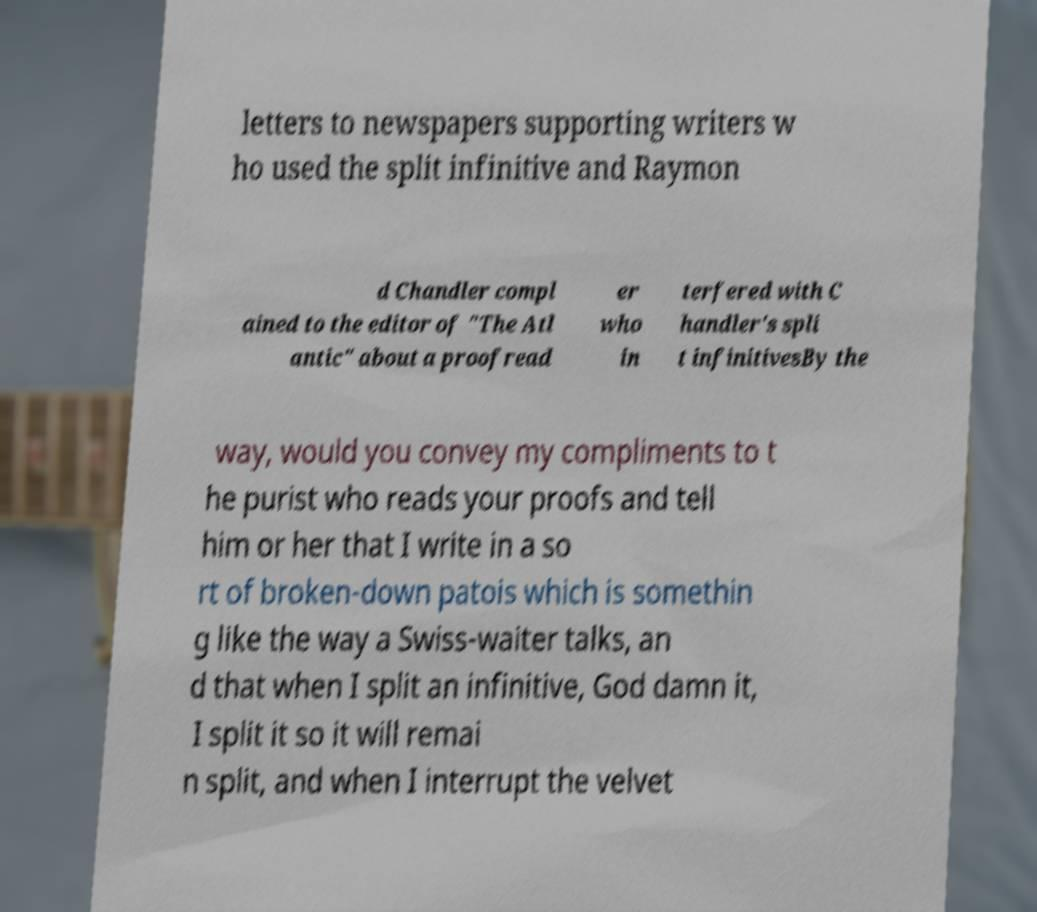Please read and relay the text visible in this image. What does it say? letters to newspapers supporting writers w ho used the split infinitive and Raymon d Chandler compl ained to the editor of "The Atl antic" about a proofread er who in terfered with C handler's spli t infinitivesBy the way, would you convey my compliments to t he purist who reads your proofs and tell him or her that I write in a so rt of broken-down patois which is somethin g like the way a Swiss-waiter talks, an d that when I split an infinitive, God damn it, I split it so it will remai n split, and when I interrupt the velvet 